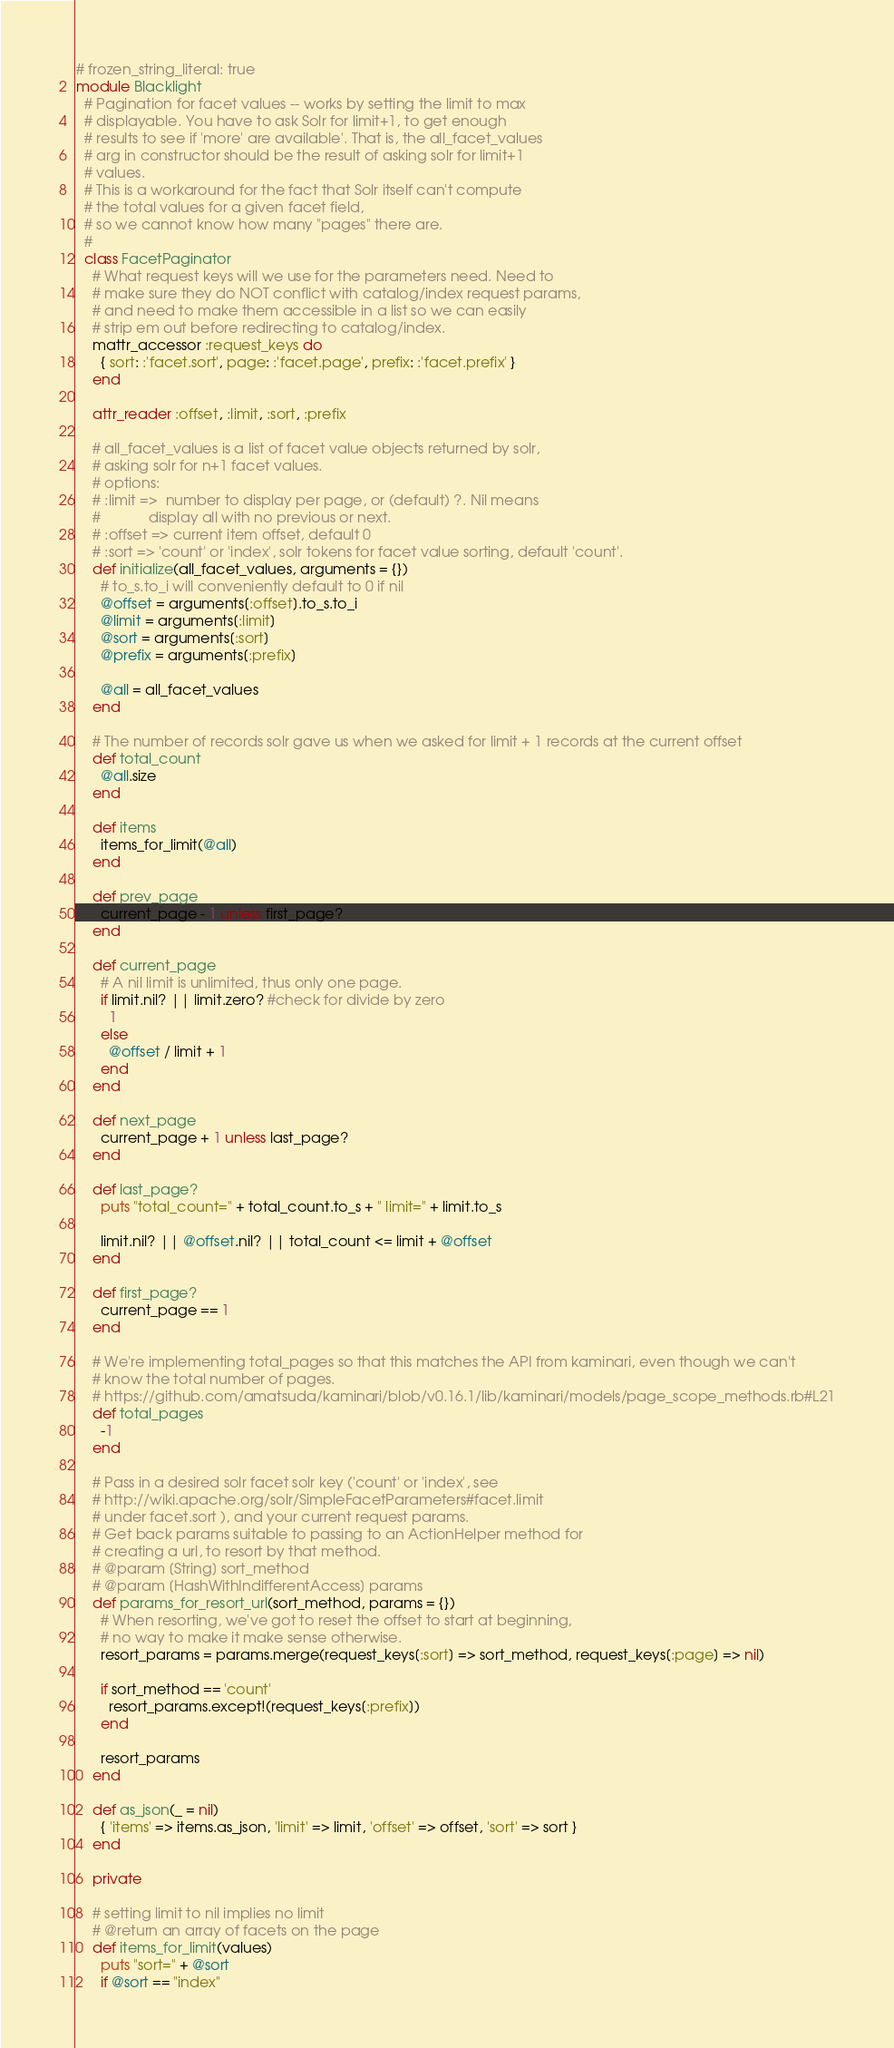Convert code to text. <code><loc_0><loc_0><loc_500><loc_500><_Ruby_># frozen_string_literal: true
module Blacklight
  # Pagination for facet values -- works by setting the limit to max
  # displayable. You have to ask Solr for limit+1, to get enough
  # results to see if 'more' are available'. That is, the all_facet_values
  # arg in constructor should be the result of asking solr for limit+1
  # values. 
  # This is a workaround for the fact that Solr itself can't compute
  # the total values for a given facet field,
  # so we cannot know how many "pages" there are.
  #
  class FacetPaginator
    # What request keys will we use for the parameters need. Need to
    # make sure they do NOT conflict with catalog/index request params,
    # and need to make them accessible in a list so we can easily
    # strip em out before redirecting to catalog/index.
    mattr_accessor :request_keys do
      { sort: :'facet.sort', page: :'facet.page', prefix: :'facet.prefix' }
    end

    attr_reader :offset, :limit, :sort, :prefix

    # all_facet_values is a list of facet value objects returned by solr,
    # asking solr for n+1 facet values.
    # options:
    # :limit =>  number to display per page, or (default) ?. Nil means
    #            display all with no previous or next. 
    # :offset => current item offset, default 0
    # :sort => 'count' or 'index', solr tokens for facet value sorting, default 'count'. 
    def initialize(all_facet_values, arguments = {})
      # to_s.to_i will conveniently default to 0 if nil
      @offset = arguments[:offset].to_s.to_i
      @limit = arguments[:limit]
      @sort = arguments[:sort]
      @prefix = arguments[:prefix]

      @all = all_facet_values
    end

    # The number of records solr gave us when we asked for limit + 1 records at the current offset
    def total_count
      @all.size
    end

    def items
      items_for_limit(@all)
    end

    def prev_page
      current_page - 1 unless first_page?
    end

    def current_page
      # A nil limit is unlimited, thus only one page.
      if limit.nil? || limit.zero? #check for divide by zero
        1
      else
        @offset / limit + 1
      end
    end

    def next_page
      current_page + 1 unless last_page?
    end

    def last_page?
	  puts "total_count=" + total_count.to_s + " limit=" + limit.to_s
	   
      limit.nil? || @offset.nil? || total_count <= limit + @offset
    end

    def first_page?
      current_page == 1
    end

    # We're implementing total_pages so that this matches the API from kaminari, even though we can't
    # know the total number of pages.
    # https://github.com/amatsuda/kaminari/blob/v0.16.1/lib/kaminari/models/page_scope_methods.rb#L21
    def total_pages
      -1
    end

    # Pass in a desired solr facet solr key ('count' or 'index', see
    # http://wiki.apache.org/solr/SimpleFacetParameters#facet.limit
    # under facet.sort ), and your current request params.
    # Get back params suitable to passing to an ActionHelper method for
    # creating a url, to resort by that method.
    # @param [String] sort_method
    # @param [HashWithIndifferentAccess] params
    def params_for_resort_url(sort_method, params = {})
      # When resorting, we've got to reset the offset to start at beginning,
      # no way to make it make sense otherwise.
      resort_params = params.merge(request_keys[:sort] => sort_method, request_keys[:page] => nil)

      if sort_method == 'count'
        resort_params.except!(request_keys[:prefix])
      end

      resort_params
    end

    def as_json(_ = nil)
      { 'items' => items.as_json, 'limit' => limit, 'offset' => offset, 'sort' => sort }
    end

    private

    # setting limit to nil implies no limit
    # @return an array of facets on the page
    def items_for_limit(values)	  
	  puts "sort=" + @sort
	  if @sort == "index"</code> 